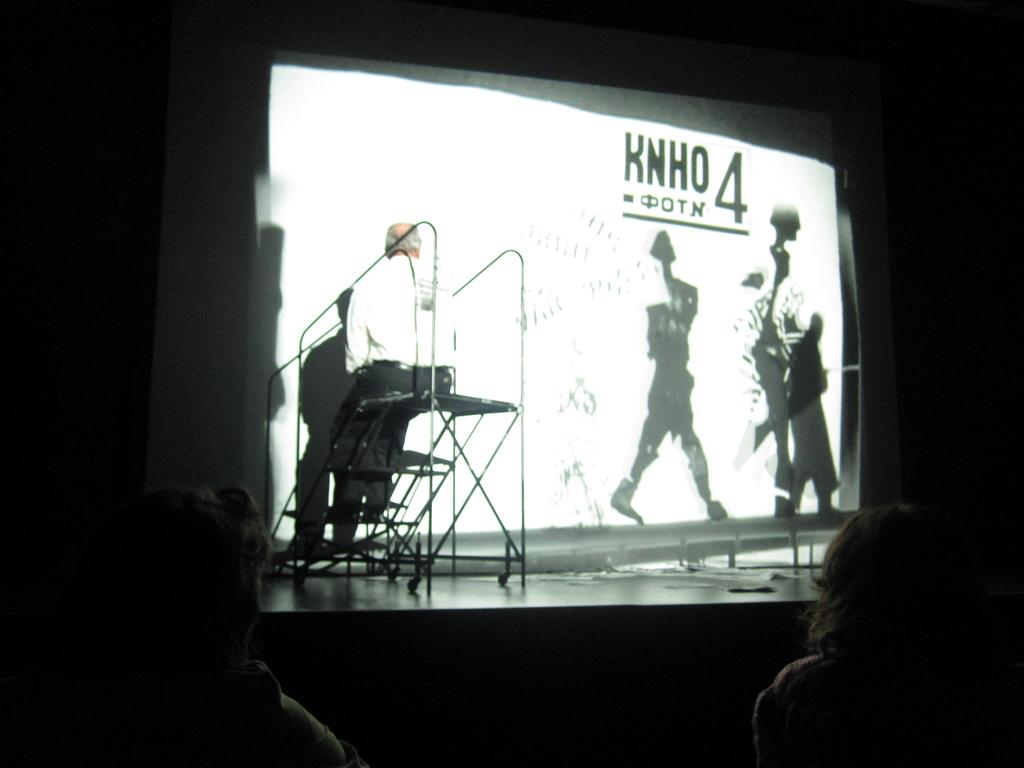How many people are present in the image? There are three people in the image. What is the man on stage sitting on? The man is sitting on an object on stage. What is in front of the man on stage? There is a screen in front of the man. What can be observed about the background of the image? The background of the image is dark. What type of trains can be seen passing by in the image? There are no trains present in the image. Can you tell me how many appliances are visible on the stage? There is no appliance visible on the stage in the image. 